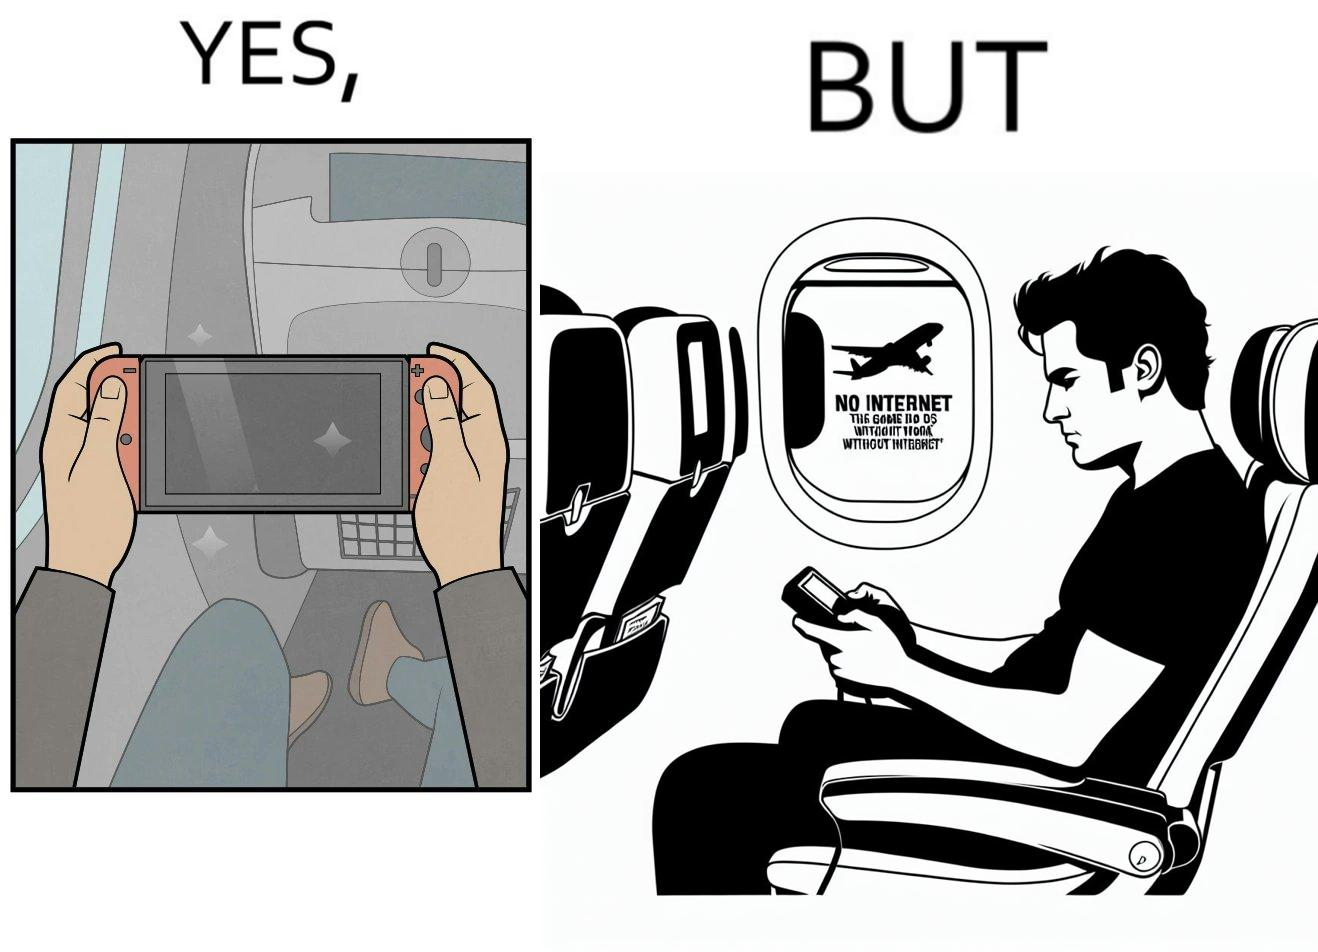Describe what you see in this image. The image is ironic, as the person is holding the game console to play a game during the flight. However, the person is unable to play the game, as the game requires internet (as is the case with many modern games), and internet is unavailable in many lights. 